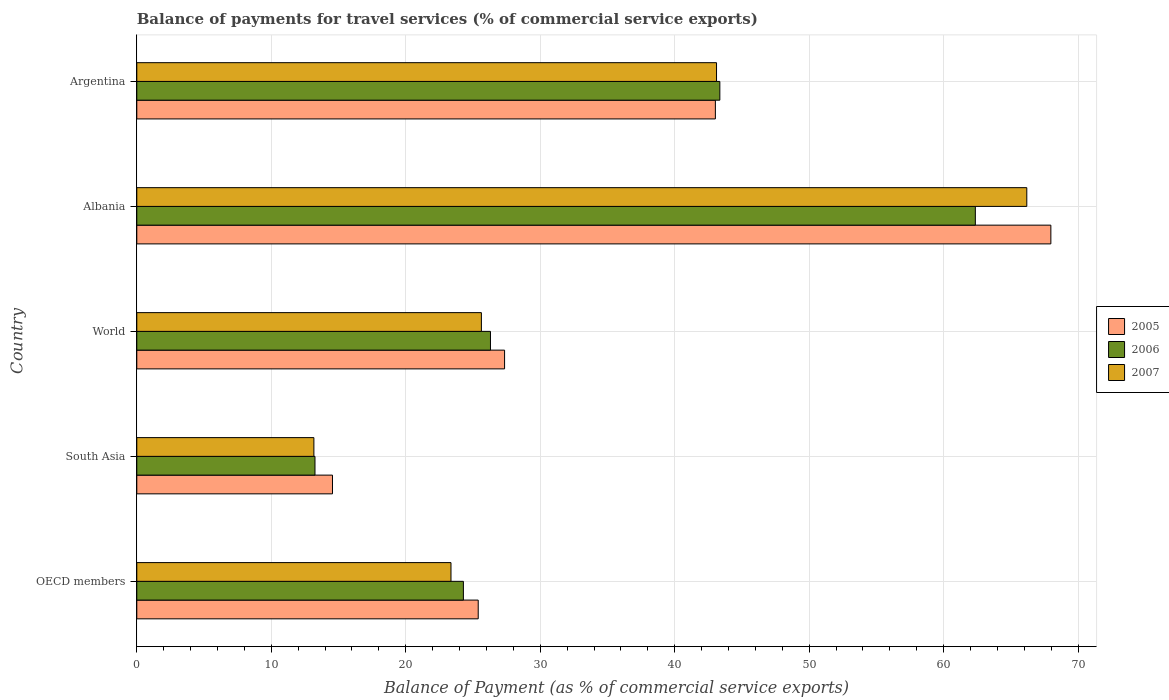How many groups of bars are there?
Your response must be concise. 5. Are the number of bars on each tick of the Y-axis equal?
Offer a terse response. Yes. How many bars are there on the 4th tick from the top?
Your answer should be very brief. 3. What is the balance of payments for travel services in 2007 in World?
Offer a terse response. 25.63. Across all countries, what is the maximum balance of payments for travel services in 2007?
Give a very brief answer. 66.18. Across all countries, what is the minimum balance of payments for travel services in 2007?
Your response must be concise. 13.17. In which country was the balance of payments for travel services in 2007 maximum?
Your answer should be very brief. Albania. In which country was the balance of payments for travel services in 2007 minimum?
Provide a succinct answer. South Asia. What is the total balance of payments for travel services in 2005 in the graph?
Keep it short and to the point. 178.29. What is the difference between the balance of payments for travel services in 2005 in South Asia and that in World?
Make the answer very short. -12.8. What is the difference between the balance of payments for travel services in 2006 in South Asia and the balance of payments for travel services in 2005 in OECD members?
Offer a very short reply. -12.14. What is the average balance of payments for travel services in 2007 per country?
Your answer should be compact. 34.29. What is the difference between the balance of payments for travel services in 2007 and balance of payments for travel services in 2005 in OECD members?
Offer a terse response. -2.03. What is the ratio of the balance of payments for travel services in 2006 in Albania to that in South Asia?
Provide a succinct answer. 4.71. What is the difference between the highest and the second highest balance of payments for travel services in 2005?
Provide a succinct answer. 24.95. What is the difference between the highest and the lowest balance of payments for travel services in 2005?
Keep it short and to the point. 53.42. In how many countries, is the balance of payments for travel services in 2007 greater than the average balance of payments for travel services in 2007 taken over all countries?
Ensure brevity in your answer.  2. Is the sum of the balance of payments for travel services in 2007 in Albania and Argentina greater than the maximum balance of payments for travel services in 2005 across all countries?
Provide a short and direct response. Yes. What does the 2nd bar from the top in Albania represents?
Give a very brief answer. 2006. Are all the bars in the graph horizontal?
Keep it short and to the point. Yes. What is the difference between two consecutive major ticks on the X-axis?
Ensure brevity in your answer.  10. Does the graph contain grids?
Offer a terse response. Yes. Where does the legend appear in the graph?
Offer a very short reply. Center right. How many legend labels are there?
Ensure brevity in your answer.  3. How are the legend labels stacked?
Offer a very short reply. Vertical. What is the title of the graph?
Give a very brief answer. Balance of payments for travel services (% of commercial service exports). Does "1983" appear as one of the legend labels in the graph?
Provide a succinct answer. No. What is the label or title of the X-axis?
Your answer should be very brief. Balance of Payment (as % of commercial service exports). What is the Balance of Payment (as % of commercial service exports) in 2005 in OECD members?
Offer a very short reply. 25.39. What is the Balance of Payment (as % of commercial service exports) of 2006 in OECD members?
Your answer should be compact. 24.29. What is the Balance of Payment (as % of commercial service exports) of 2007 in OECD members?
Offer a terse response. 23.36. What is the Balance of Payment (as % of commercial service exports) of 2005 in South Asia?
Provide a succinct answer. 14.55. What is the Balance of Payment (as % of commercial service exports) in 2006 in South Asia?
Your answer should be compact. 13.25. What is the Balance of Payment (as % of commercial service exports) of 2007 in South Asia?
Ensure brevity in your answer.  13.17. What is the Balance of Payment (as % of commercial service exports) of 2005 in World?
Your answer should be very brief. 27.35. What is the Balance of Payment (as % of commercial service exports) in 2006 in World?
Your response must be concise. 26.3. What is the Balance of Payment (as % of commercial service exports) of 2007 in World?
Keep it short and to the point. 25.63. What is the Balance of Payment (as % of commercial service exports) in 2005 in Albania?
Your answer should be compact. 67.97. What is the Balance of Payment (as % of commercial service exports) in 2006 in Albania?
Your response must be concise. 62.36. What is the Balance of Payment (as % of commercial service exports) in 2007 in Albania?
Make the answer very short. 66.18. What is the Balance of Payment (as % of commercial service exports) in 2005 in Argentina?
Provide a succinct answer. 43.03. What is the Balance of Payment (as % of commercial service exports) of 2006 in Argentina?
Provide a short and direct response. 43.36. What is the Balance of Payment (as % of commercial service exports) in 2007 in Argentina?
Give a very brief answer. 43.11. Across all countries, what is the maximum Balance of Payment (as % of commercial service exports) in 2005?
Ensure brevity in your answer.  67.97. Across all countries, what is the maximum Balance of Payment (as % of commercial service exports) of 2006?
Offer a very short reply. 62.36. Across all countries, what is the maximum Balance of Payment (as % of commercial service exports) in 2007?
Your response must be concise. 66.18. Across all countries, what is the minimum Balance of Payment (as % of commercial service exports) of 2005?
Your response must be concise. 14.55. Across all countries, what is the minimum Balance of Payment (as % of commercial service exports) of 2006?
Your answer should be compact. 13.25. Across all countries, what is the minimum Balance of Payment (as % of commercial service exports) of 2007?
Provide a succinct answer. 13.17. What is the total Balance of Payment (as % of commercial service exports) in 2005 in the graph?
Provide a succinct answer. 178.29. What is the total Balance of Payment (as % of commercial service exports) in 2006 in the graph?
Provide a short and direct response. 169.56. What is the total Balance of Payment (as % of commercial service exports) in 2007 in the graph?
Your response must be concise. 171.46. What is the difference between the Balance of Payment (as % of commercial service exports) in 2005 in OECD members and that in South Asia?
Ensure brevity in your answer.  10.84. What is the difference between the Balance of Payment (as % of commercial service exports) in 2006 in OECD members and that in South Asia?
Give a very brief answer. 11.04. What is the difference between the Balance of Payment (as % of commercial service exports) in 2007 in OECD members and that in South Asia?
Ensure brevity in your answer.  10.2. What is the difference between the Balance of Payment (as % of commercial service exports) of 2005 in OECD members and that in World?
Your answer should be compact. -1.96. What is the difference between the Balance of Payment (as % of commercial service exports) in 2006 in OECD members and that in World?
Provide a succinct answer. -2.01. What is the difference between the Balance of Payment (as % of commercial service exports) in 2007 in OECD members and that in World?
Ensure brevity in your answer.  -2.26. What is the difference between the Balance of Payment (as % of commercial service exports) of 2005 in OECD members and that in Albania?
Your response must be concise. -42.58. What is the difference between the Balance of Payment (as % of commercial service exports) in 2006 in OECD members and that in Albania?
Your answer should be compact. -38.07. What is the difference between the Balance of Payment (as % of commercial service exports) in 2007 in OECD members and that in Albania?
Your response must be concise. -42.82. What is the difference between the Balance of Payment (as % of commercial service exports) in 2005 in OECD members and that in Argentina?
Provide a short and direct response. -17.64. What is the difference between the Balance of Payment (as % of commercial service exports) of 2006 in OECD members and that in Argentina?
Make the answer very short. -19.07. What is the difference between the Balance of Payment (as % of commercial service exports) of 2007 in OECD members and that in Argentina?
Make the answer very short. -19.75. What is the difference between the Balance of Payment (as % of commercial service exports) in 2005 in South Asia and that in World?
Provide a succinct answer. -12.8. What is the difference between the Balance of Payment (as % of commercial service exports) of 2006 in South Asia and that in World?
Make the answer very short. -13.05. What is the difference between the Balance of Payment (as % of commercial service exports) in 2007 in South Asia and that in World?
Offer a terse response. -12.46. What is the difference between the Balance of Payment (as % of commercial service exports) in 2005 in South Asia and that in Albania?
Your answer should be very brief. -53.42. What is the difference between the Balance of Payment (as % of commercial service exports) in 2006 in South Asia and that in Albania?
Your answer should be very brief. -49.11. What is the difference between the Balance of Payment (as % of commercial service exports) in 2007 in South Asia and that in Albania?
Provide a succinct answer. -53.02. What is the difference between the Balance of Payment (as % of commercial service exports) of 2005 in South Asia and that in Argentina?
Provide a succinct answer. -28.47. What is the difference between the Balance of Payment (as % of commercial service exports) of 2006 in South Asia and that in Argentina?
Provide a succinct answer. -30.11. What is the difference between the Balance of Payment (as % of commercial service exports) in 2007 in South Asia and that in Argentina?
Offer a terse response. -29.94. What is the difference between the Balance of Payment (as % of commercial service exports) of 2005 in World and that in Albania?
Your response must be concise. -40.62. What is the difference between the Balance of Payment (as % of commercial service exports) of 2006 in World and that in Albania?
Make the answer very short. -36.06. What is the difference between the Balance of Payment (as % of commercial service exports) in 2007 in World and that in Albania?
Give a very brief answer. -40.56. What is the difference between the Balance of Payment (as % of commercial service exports) of 2005 in World and that in Argentina?
Provide a succinct answer. -15.68. What is the difference between the Balance of Payment (as % of commercial service exports) of 2006 in World and that in Argentina?
Make the answer very short. -17.06. What is the difference between the Balance of Payment (as % of commercial service exports) in 2007 in World and that in Argentina?
Give a very brief answer. -17.49. What is the difference between the Balance of Payment (as % of commercial service exports) in 2005 in Albania and that in Argentina?
Keep it short and to the point. 24.95. What is the difference between the Balance of Payment (as % of commercial service exports) of 2006 in Albania and that in Argentina?
Keep it short and to the point. 19. What is the difference between the Balance of Payment (as % of commercial service exports) in 2007 in Albania and that in Argentina?
Ensure brevity in your answer.  23.07. What is the difference between the Balance of Payment (as % of commercial service exports) of 2005 in OECD members and the Balance of Payment (as % of commercial service exports) of 2006 in South Asia?
Your response must be concise. 12.14. What is the difference between the Balance of Payment (as % of commercial service exports) in 2005 in OECD members and the Balance of Payment (as % of commercial service exports) in 2007 in South Asia?
Your response must be concise. 12.22. What is the difference between the Balance of Payment (as % of commercial service exports) in 2006 in OECD members and the Balance of Payment (as % of commercial service exports) in 2007 in South Asia?
Offer a terse response. 11.12. What is the difference between the Balance of Payment (as % of commercial service exports) of 2005 in OECD members and the Balance of Payment (as % of commercial service exports) of 2006 in World?
Provide a short and direct response. -0.91. What is the difference between the Balance of Payment (as % of commercial service exports) in 2005 in OECD members and the Balance of Payment (as % of commercial service exports) in 2007 in World?
Provide a succinct answer. -0.24. What is the difference between the Balance of Payment (as % of commercial service exports) of 2006 in OECD members and the Balance of Payment (as % of commercial service exports) of 2007 in World?
Offer a terse response. -1.34. What is the difference between the Balance of Payment (as % of commercial service exports) in 2005 in OECD members and the Balance of Payment (as % of commercial service exports) in 2006 in Albania?
Your answer should be compact. -36.97. What is the difference between the Balance of Payment (as % of commercial service exports) of 2005 in OECD members and the Balance of Payment (as % of commercial service exports) of 2007 in Albania?
Make the answer very short. -40.8. What is the difference between the Balance of Payment (as % of commercial service exports) of 2006 in OECD members and the Balance of Payment (as % of commercial service exports) of 2007 in Albania?
Offer a very short reply. -41.9. What is the difference between the Balance of Payment (as % of commercial service exports) of 2005 in OECD members and the Balance of Payment (as % of commercial service exports) of 2006 in Argentina?
Ensure brevity in your answer.  -17.97. What is the difference between the Balance of Payment (as % of commercial service exports) in 2005 in OECD members and the Balance of Payment (as % of commercial service exports) in 2007 in Argentina?
Provide a succinct answer. -17.72. What is the difference between the Balance of Payment (as % of commercial service exports) of 2006 in OECD members and the Balance of Payment (as % of commercial service exports) of 2007 in Argentina?
Give a very brief answer. -18.83. What is the difference between the Balance of Payment (as % of commercial service exports) in 2005 in South Asia and the Balance of Payment (as % of commercial service exports) in 2006 in World?
Your answer should be compact. -11.75. What is the difference between the Balance of Payment (as % of commercial service exports) in 2005 in South Asia and the Balance of Payment (as % of commercial service exports) in 2007 in World?
Provide a succinct answer. -11.07. What is the difference between the Balance of Payment (as % of commercial service exports) of 2006 in South Asia and the Balance of Payment (as % of commercial service exports) of 2007 in World?
Your answer should be very brief. -12.38. What is the difference between the Balance of Payment (as % of commercial service exports) of 2005 in South Asia and the Balance of Payment (as % of commercial service exports) of 2006 in Albania?
Your response must be concise. -47.81. What is the difference between the Balance of Payment (as % of commercial service exports) in 2005 in South Asia and the Balance of Payment (as % of commercial service exports) in 2007 in Albania?
Your answer should be compact. -51.63. What is the difference between the Balance of Payment (as % of commercial service exports) in 2006 in South Asia and the Balance of Payment (as % of commercial service exports) in 2007 in Albania?
Your answer should be compact. -52.93. What is the difference between the Balance of Payment (as % of commercial service exports) in 2005 in South Asia and the Balance of Payment (as % of commercial service exports) in 2006 in Argentina?
Your answer should be very brief. -28.81. What is the difference between the Balance of Payment (as % of commercial service exports) of 2005 in South Asia and the Balance of Payment (as % of commercial service exports) of 2007 in Argentina?
Your response must be concise. -28.56. What is the difference between the Balance of Payment (as % of commercial service exports) of 2006 in South Asia and the Balance of Payment (as % of commercial service exports) of 2007 in Argentina?
Your answer should be compact. -29.86. What is the difference between the Balance of Payment (as % of commercial service exports) of 2005 in World and the Balance of Payment (as % of commercial service exports) of 2006 in Albania?
Your answer should be very brief. -35.01. What is the difference between the Balance of Payment (as % of commercial service exports) in 2005 in World and the Balance of Payment (as % of commercial service exports) in 2007 in Albania?
Provide a succinct answer. -38.83. What is the difference between the Balance of Payment (as % of commercial service exports) in 2006 in World and the Balance of Payment (as % of commercial service exports) in 2007 in Albania?
Give a very brief answer. -39.88. What is the difference between the Balance of Payment (as % of commercial service exports) in 2005 in World and the Balance of Payment (as % of commercial service exports) in 2006 in Argentina?
Provide a succinct answer. -16.01. What is the difference between the Balance of Payment (as % of commercial service exports) of 2005 in World and the Balance of Payment (as % of commercial service exports) of 2007 in Argentina?
Give a very brief answer. -15.76. What is the difference between the Balance of Payment (as % of commercial service exports) of 2006 in World and the Balance of Payment (as % of commercial service exports) of 2007 in Argentina?
Offer a terse response. -16.81. What is the difference between the Balance of Payment (as % of commercial service exports) of 2005 in Albania and the Balance of Payment (as % of commercial service exports) of 2006 in Argentina?
Offer a very short reply. 24.62. What is the difference between the Balance of Payment (as % of commercial service exports) of 2005 in Albania and the Balance of Payment (as % of commercial service exports) of 2007 in Argentina?
Your answer should be compact. 24.86. What is the difference between the Balance of Payment (as % of commercial service exports) in 2006 in Albania and the Balance of Payment (as % of commercial service exports) in 2007 in Argentina?
Provide a short and direct response. 19.25. What is the average Balance of Payment (as % of commercial service exports) in 2005 per country?
Offer a terse response. 35.66. What is the average Balance of Payment (as % of commercial service exports) of 2006 per country?
Offer a very short reply. 33.91. What is the average Balance of Payment (as % of commercial service exports) of 2007 per country?
Provide a short and direct response. 34.29. What is the difference between the Balance of Payment (as % of commercial service exports) of 2005 and Balance of Payment (as % of commercial service exports) of 2006 in OECD members?
Keep it short and to the point. 1.1. What is the difference between the Balance of Payment (as % of commercial service exports) in 2005 and Balance of Payment (as % of commercial service exports) in 2007 in OECD members?
Your answer should be very brief. 2.03. What is the difference between the Balance of Payment (as % of commercial service exports) of 2006 and Balance of Payment (as % of commercial service exports) of 2007 in OECD members?
Your answer should be very brief. 0.92. What is the difference between the Balance of Payment (as % of commercial service exports) of 2005 and Balance of Payment (as % of commercial service exports) of 2006 in South Asia?
Provide a short and direct response. 1.3. What is the difference between the Balance of Payment (as % of commercial service exports) in 2005 and Balance of Payment (as % of commercial service exports) in 2007 in South Asia?
Your answer should be very brief. 1.38. What is the difference between the Balance of Payment (as % of commercial service exports) of 2006 and Balance of Payment (as % of commercial service exports) of 2007 in South Asia?
Provide a short and direct response. 0.08. What is the difference between the Balance of Payment (as % of commercial service exports) of 2005 and Balance of Payment (as % of commercial service exports) of 2006 in World?
Provide a succinct answer. 1.05. What is the difference between the Balance of Payment (as % of commercial service exports) of 2005 and Balance of Payment (as % of commercial service exports) of 2007 in World?
Your answer should be compact. 1.72. What is the difference between the Balance of Payment (as % of commercial service exports) in 2006 and Balance of Payment (as % of commercial service exports) in 2007 in World?
Provide a succinct answer. 0.68. What is the difference between the Balance of Payment (as % of commercial service exports) in 2005 and Balance of Payment (as % of commercial service exports) in 2006 in Albania?
Offer a very short reply. 5.62. What is the difference between the Balance of Payment (as % of commercial service exports) in 2005 and Balance of Payment (as % of commercial service exports) in 2007 in Albania?
Offer a terse response. 1.79. What is the difference between the Balance of Payment (as % of commercial service exports) in 2006 and Balance of Payment (as % of commercial service exports) in 2007 in Albania?
Provide a short and direct response. -3.83. What is the difference between the Balance of Payment (as % of commercial service exports) in 2005 and Balance of Payment (as % of commercial service exports) in 2006 in Argentina?
Your response must be concise. -0.33. What is the difference between the Balance of Payment (as % of commercial service exports) in 2005 and Balance of Payment (as % of commercial service exports) in 2007 in Argentina?
Offer a terse response. -0.09. What is the difference between the Balance of Payment (as % of commercial service exports) of 2006 and Balance of Payment (as % of commercial service exports) of 2007 in Argentina?
Your answer should be very brief. 0.25. What is the ratio of the Balance of Payment (as % of commercial service exports) of 2005 in OECD members to that in South Asia?
Provide a short and direct response. 1.74. What is the ratio of the Balance of Payment (as % of commercial service exports) of 2006 in OECD members to that in South Asia?
Your answer should be compact. 1.83. What is the ratio of the Balance of Payment (as % of commercial service exports) in 2007 in OECD members to that in South Asia?
Your response must be concise. 1.77. What is the ratio of the Balance of Payment (as % of commercial service exports) of 2005 in OECD members to that in World?
Keep it short and to the point. 0.93. What is the ratio of the Balance of Payment (as % of commercial service exports) in 2006 in OECD members to that in World?
Ensure brevity in your answer.  0.92. What is the ratio of the Balance of Payment (as % of commercial service exports) in 2007 in OECD members to that in World?
Provide a succinct answer. 0.91. What is the ratio of the Balance of Payment (as % of commercial service exports) of 2005 in OECD members to that in Albania?
Give a very brief answer. 0.37. What is the ratio of the Balance of Payment (as % of commercial service exports) in 2006 in OECD members to that in Albania?
Provide a succinct answer. 0.39. What is the ratio of the Balance of Payment (as % of commercial service exports) in 2007 in OECD members to that in Albania?
Provide a succinct answer. 0.35. What is the ratio of the Balance of Payment (as % of commercial service exports) in 2005 in OECD members to that in Argentina?
Your answer should be very brief. 0.59. What is the ratio of the Balance of Payment (as % of commercial service exports) of 2006 in OECD members to that in Argentina?
Your answer should be compact. 0.56. What is the ratio of the Balance of Payment (as % of commercial service exports) in 2007 in OECD members to that in Argentina?
Give a very brief answer. 0.54. What is the ratio of the Balance of Payment (as % of commercial service exports) in 2005 in South Asia to that in World?
Ensure brevity in your answer.  0.53. What is the ratio of the Balance of Payment (as % of commercial service exports) of 2006 in South Asia to that in World?
Provide a succinct answer. 0.5. What is the ratio of the Balance of Payment (as % of commercial service exports) of 2007 in South Asia to that in World?
Offer a very short reply. 0.51. What is the ratio of the Balance of Payment (as % of commercial service exports) in 2005 in South Asia to that in Albania?
Keep it short and to the point. 0.21. What is the ratio of the Balance of Payment (as % of commercial service exports) of 2006 in South Asia to that in Albania?
Give a very brief answer. 0.21. What is the ratio of the Balance of Payment (as % of commercial service exports) in 2007 in South Asia to that in Albania?
Your response must be concise. 0.2. What is the ratio of the Balance of Payment (as % of commercial service exports) of 2005 in South Asia to that in Argentina?
Keep it short and to the point. 0.34. What is the ratio of the Balance of Payment (as % of commercial service exports) of 2006 in South Asia to that in Argentina?
Offer a very short reply. 0.31. What is the ratio of the Balance of Payment (as % of commercial service exports) of 2007 in South Asia to that in Argentina?
Ensure brevity in your answer.  0.31. What is the ratio of the Balance of Payment (as % of commercial service exports) of 2005 in World to that in Albania?
Give a very brief answer. 0.4. What is the ratio of the Balance of Payment (as % of commercial service exports) of 2006 in World to that in Albania?
Keep it short and to the point. 0.42. What is the ratio of the Balance of Payment (as % of commercial service exports) of 2007 in World to that in Albania?
Keep it short and to the point. 0.39. What is the ratio of the Balance of Payment (as % of commercial service exports) in 2005 in World to that in Argentina?
Your answer should be very brief. 0.64. What is the ratio of the Balance of Payment (as % of commercial service exports) in 2006 in World to that in Argentina?
Your answer should be very brief. 0.61. What is the ratio of the Balance of Payment (as % of commercial service exports) in 2007 in World to that in Argentina?
Provide a short and direct response. 0.59. What is the ratio of the Balance of Payment (as % of commercial service exports) in 2005 in Albania to that in Argentina?
Ensure brevity in your answer.  1.58. What is the ratio of the Balance of Payment (as % of commercial service exports) of 2006 in Albania to that in Argentina?
Provide a succinct answer. 1.44. What is the ratio of the Balance of Payment (as % of commercial service exports) of 2007 in Albania to that in Argentina?
Make the answer very short. 1.54. What is the difference between the highest and the second highest Balance of Payment (as % of commercial service exports) in 2005?
Keep it short and to the point. 24.95. What is the difference between the highest and the second highest Balance of Payment (as % of commercial service exports) of 2006?
Your answer should be very brief. 19. What is the difference between the highest and the second highest Balance of Payment (as % of commercial service exports) in 2007?
Your response must be concise. 23.07. What is the difference between the highest and the lowest Balance of Payment (as % of commercial service exports) in 2005?
Your answer should be very brief. 53.42. What is the difference between the highest and the lowest Balance of Payment (as % of commercial service exports) in 2006?
Your answer should be very brief. 49.11. What is the difference between the highest and the lowest Balance of Payment (as % of commercial service exports) in 2007?
Your answer should be very brief. 53.02. 